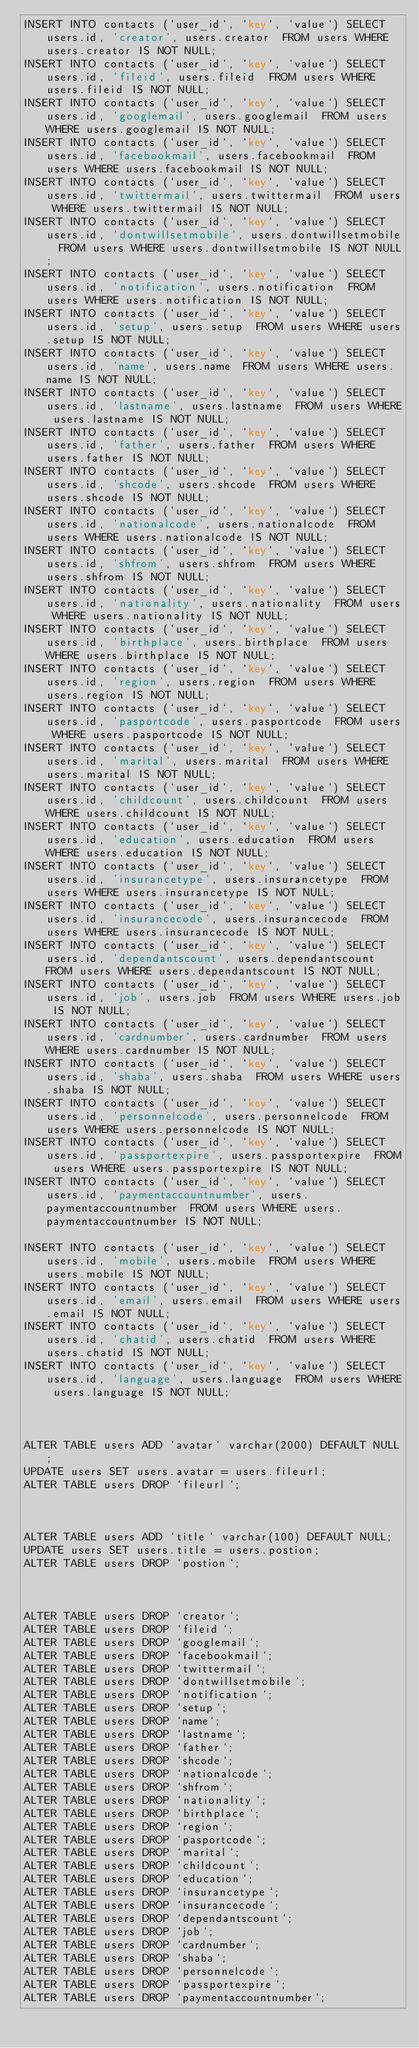<code> <loc_0><loc_0><loc_500><loc_500><_SQL_>INSERT INTO contacts (`user_id`, `key`, `value`) SELECT users.id, 'creator', users.creator  FROM users WHERE users.creator IS NOT NULL;
INSERT INTO contacts (`user_id`, `key`, `value`) SELECT users.id, 'fileid', users.fileid  FROM users WHERE users.fileid IS NOT NULL;
INSERT INTO contacts (`user_id`, `key`, `value`) SELECT users.id, 'googlemail', users.googlemail  FROM users WHERE users.googlemail IS NOT NULL;
INSERT INTO contacts (`user_id`, `key`, `value`) SELECT users.id, 'facebookmail', users.facebookmail  FROM users WHERE users.facebookmail IS NOT NULL;
INSERT INTO contacts (`user_id`, `key`, `value`) SELECT users.id, 'twittermail', users.twittermail  FROM users WHERE users.twittermail IS NOT NULL;
INSERT INTO contacts (`user_id`, `key`, `value`) SELECT users.id, 'dontwillsetmobile', users.dontwillsetmobile  FROM users WHERE users.dontwillsetmobile IS NOT NULL;
INSERT INTO contacts (`user_id`, `key`, `value`) SELECT users.id, 'notification', users.notification  FROM users WHERE users.notification IS NOT NULL;
INSERT INTO contacts (`user_id`, `key`, `value`) SELECT users.id, 'setup', users.setup  FROM users WHERE users.setup IS NOT NULL;
INSERT INTO contacts (`user_id`, `key`, `value`) SELECT users.id, 'name', users.name  FROM users WHERE users.name IS NOT NULL;
INSERT INTO contacts (`user_id`, `key`, `value`) SELECT users.id, 'lastname', users.lastname  FROM users WHERE users.lastname IS NOT NULL;
INSERT INTO contacts (`user_id`, `key`, `value`) SELECT users.id, 'father', users.father  FROM users WHERE users.father IS NOT NULL;
INSERT INTO contacts (`user_id`, `key`, `value`) SELECT users.id, 'shcode', users.shcode  FROM users WHERE users.shcode IS NOT NULL;
INSERT INTO contacts (`user_id`, `key`, `value`) SELECT users.id, 'nationalcode', users.nationalcode  FROM users WHERE users.nationalcode IS NOT NULL;
INSERT INTO contacts (`user_id`, `key`, `value`) SELECT users.id, 'shfrom', users.shfrom  FROM users WHERE users.shfrom IS NOT NULL;
INSERT INTO contacts (`user_id`, `key`, `value`) SELECT users.id, 'nationality', users.nationality  FROM users WHERE users.nationality IS NOT NULL;
INSERT INTO contacts (`user_id`, `key`, `value`) SELECT users.id, 'birthplace', users.birthplace  FROM users WHERE users.birthplace IS NOT NULL;
INSERT INTO contacts (`user_id`, `key`, `value`) SELECT users.id, 'region', users.region  FROM users WHERE users.region IS NOT NULL;
INSERT INTO contacts (`user_id`, `key`, `value`) SELECT users.id, 'pasportcode', users.pasportcode  FROM users WHERE users.pasportcode IS NOT NULL;
INSERT INTO contacts (`user_id`, `key`, `value`) SELECT users.id, 'marital', users.marital  FROM users WHERE users.marital IS NOT NULL;
INSERT INTO contacts (`user_id`, `key`, `value`) SELECT users.id, 'childcount', users.childcount  FROM users WHERE users.childcount IS NOT NULL;
INSERT INTO contacts (`user_id`, `key`, `value`) SELECT users.id, 'education', users.education  FROM users WHERE users.education IS NOT NULL;
INSERT INTO contacts (`user_id`, `key`, `value`) SELECT users.id, 'insurancetype', users.insurancetype  FROM users WHERE users.insurancetype IS NOT NULL;
INSERT INTO contacts (`user_id`, `key`, `value`) SELECT users.id, 'insurancecode', users.insurancecode  FROM users WHERE users.insurancecode IS NOT NULL;
INSERT INTO contacts (`user_id`, `key`, `value`) SELECT users.id, 'dependantscount', users.dependantscount  FROM users WHERE users.dependantscount IS NOT NULL;
INSERT INTO contacts (`user_id`, `key`, `value`) SELECT users.id, 'job', users.job  FROM users WHERE users.job IS NOT NULL;
INSERT INTO contacts (`user_id`, `key`, `value`) SELECT users.id, 'cardnumber', users.cardnumber  FROM users WHERE users.cardnumber IS NOT NULL;
INSERT INTO contacts (`user_id`, `key`, `value`) SELECT users.id, 'shaba', users.shaba  FROM users WHERE users.shaba IS NOT NULL;
INSERT INTO contacts (`user_id`, `key`, `value`) SELECT users.id, 'personnelcode', users.personnelcode  FROM users WHERE users.personnelcode IS NOT NULL;
INSERT INTO contacts (`user_id`, `key`, `value`) SELECT users.id, 'passportexpire', users.passportexpire  FROM users WHERE users.passportexpire IS NOT NULL;
INSERT INTO contacts (`user_id`, `key`, `value`) SELECT users.id, 'paymentaccountnumber', users.paymentaccountnumber  FROM users WHERE users.paymentaccountnumber IS NOT NULL;

INSERT INTO contacts (`user_id`, `key`, `value`) SELECT users.id, 'mobile', users.mobile  FROM users WHERE users.mobile IS NOT NULL;
INSERT INTO contacts (`user_id`, `key`, `value`) SELECT users.id, 'email', users.email  FROM users WHERE users.email IS NOT NULL;
INSERT INTO contacts (`user_id`, `key`, `value`) SELECT users.id, 'chatid', users.chatid  FROM users WHERE users.chatid IS NOT NULL;
INSERT INTO contacts (`user_id`, `key`, `value`) SELECT users.id, 'language', users.language  FROM users WHERE users.language IS NOT NULL;



ALTER TABLE users ADD `avatar` varchar(2000) DEFAULT NULL;
UPDATE users SET users.avatar = users.fileurl;
ALTER TABLE users DROP `fileurl`;



ALTER TABLE users ADD `title` varchar(100) DEFAULT NULL;
UPDATE users SET users.title = users.postion;
ALTER TABLE users DROP `postion`;



ALTER TABLE users DROP `creator`;
ALTER TABLE users DROP `fileid`;
ALTER TABLE users DROP `googlemail`;
ALTER TABLE users DROP `facebookmail`;
ALTER TABLE users DROP `twittermail`;
ALTER TABLE users DROP `dontwillsetmobile`;
ALTER TABLE users DROP `notification`;
ALTER TABLE users DROP `setup`;
ALTER TABLE users DROP `name`;
ALTER TABLE users DROP `lastname`;
ALTER TABLE users DROP `father`;
ALTER TABLE users DROP `shcode`;
ALTER TABLE users DROP `nationalcode`;
ALTER TABLE users DROP `shfrom`;
ALTER TABLE users DROP `nationality`;
ALTER TABLE users DROP `birthplace`;
ALTER TABLE users DROP `region`;
ALTER TABLE users DROP `pasportcode`;
ALTER TABLE users DROP `marital`;
ALTER TABLE users DROP `childcount`;
ALTER TABLE users DROP `education`;
ALTER TABLE users DROP `insurancetype`;
ALTER TABLE users DROP `insurancecode`;
ALTER TABLE users DROP `dependantscount`;
ALTER TABLE users DROP `job`;
ALTER TABLE users DROP `cardnumber`;
ALTER TABLE users DROP `shaba`;
ALTER TABLE users DROP `personnelcode`;
ALTER TABLE users DROP `passportexpire`;
ALTER TABLE users DROP `paymentaccountnumber`;




</code> 